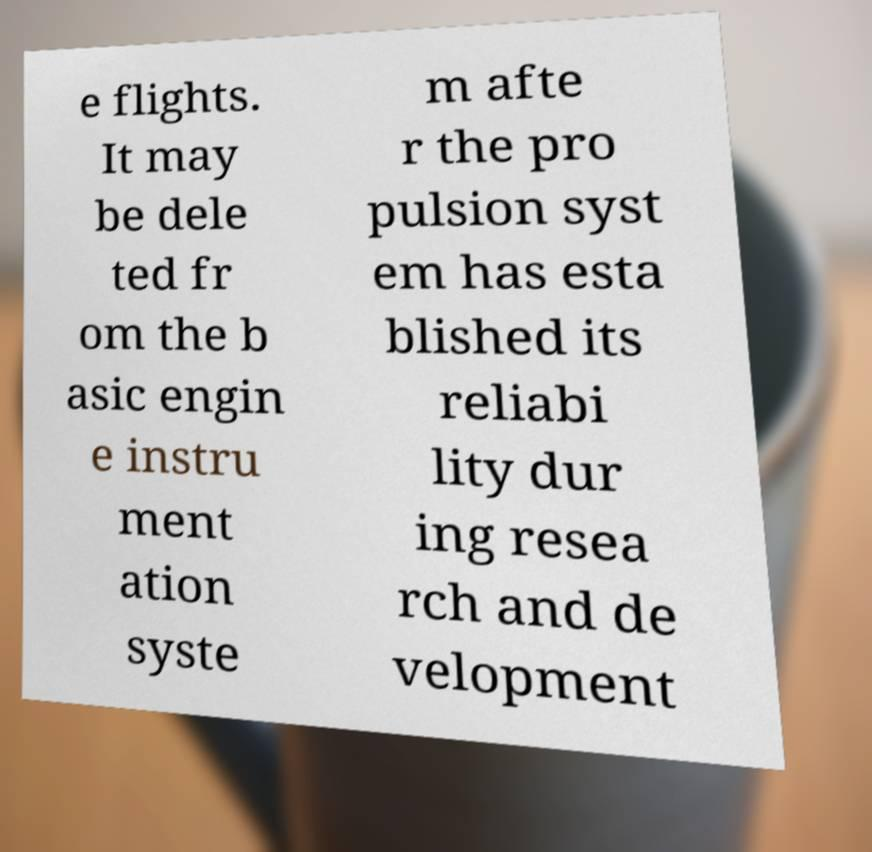Can you accurately transcribe the text from the provided image for me? e flights. It may be dele ted fr om the b asic engin e instru ment ation syste m afte r the pro pulsion syst em has esta blished its reliabi lity dur ing resea rch and de velopment 